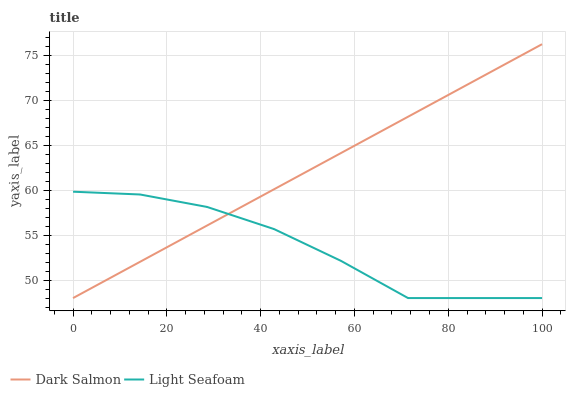Does Light Seafoam have the minimum area under the curve?
Answer yes or no. Yes. Does Dark Salmon have the maximum area under the curve?
Answer yes or no. Yes. Does Dark Salmon have the minimum area under the curve?
Answer yes or no. No. Is Dark Salmon the smoothest?
Answer yes or no. Yes. Is Light Seafoam the roughest?
Answer yes or no. Yes. Is Dark Salmon the roughest?
Answer yes or no. No. Does Light Seafoam have the lowest value?
Answer yes or no. Yes. Does Dark Salmon have the highest value?
Answer yes or no. Yes. Does Light Seafoam intersect Dark Salmon?
Answer yes or no. Yes. Is Light Seafoam less than Dark Salmon?
Answer yes or no. No. Is Light Seafoam greater than Dark Salmon?
Answer yes or no. No. 